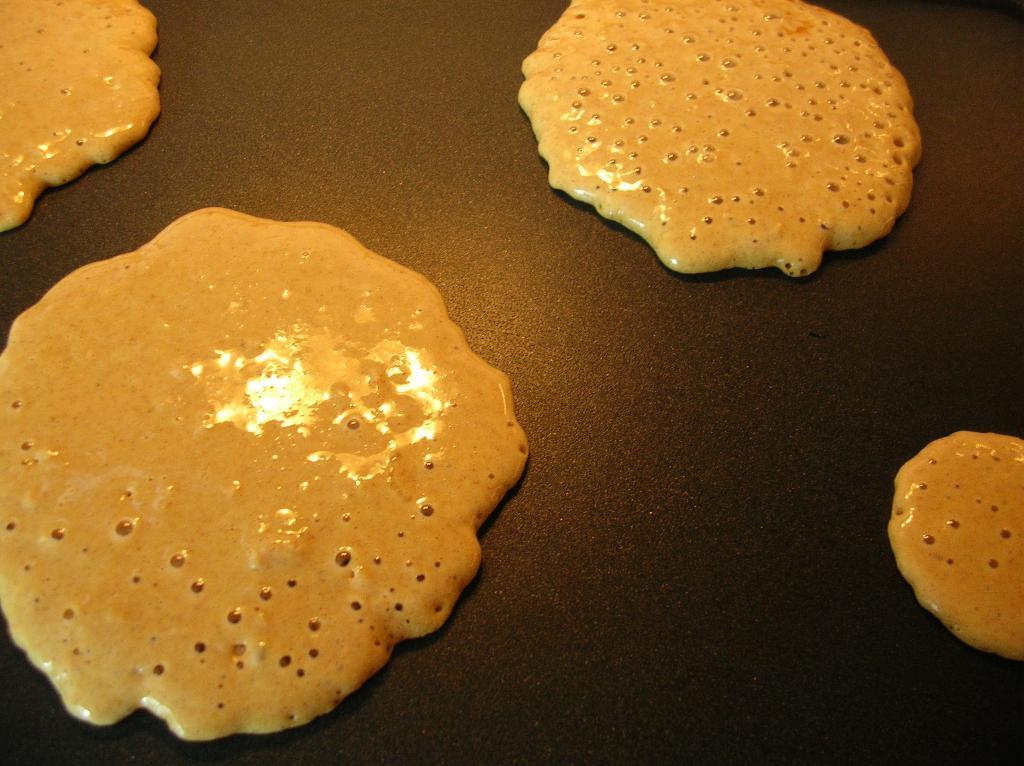How would you summarize this image in a sentence or two? In this picture we can see pancakes. 